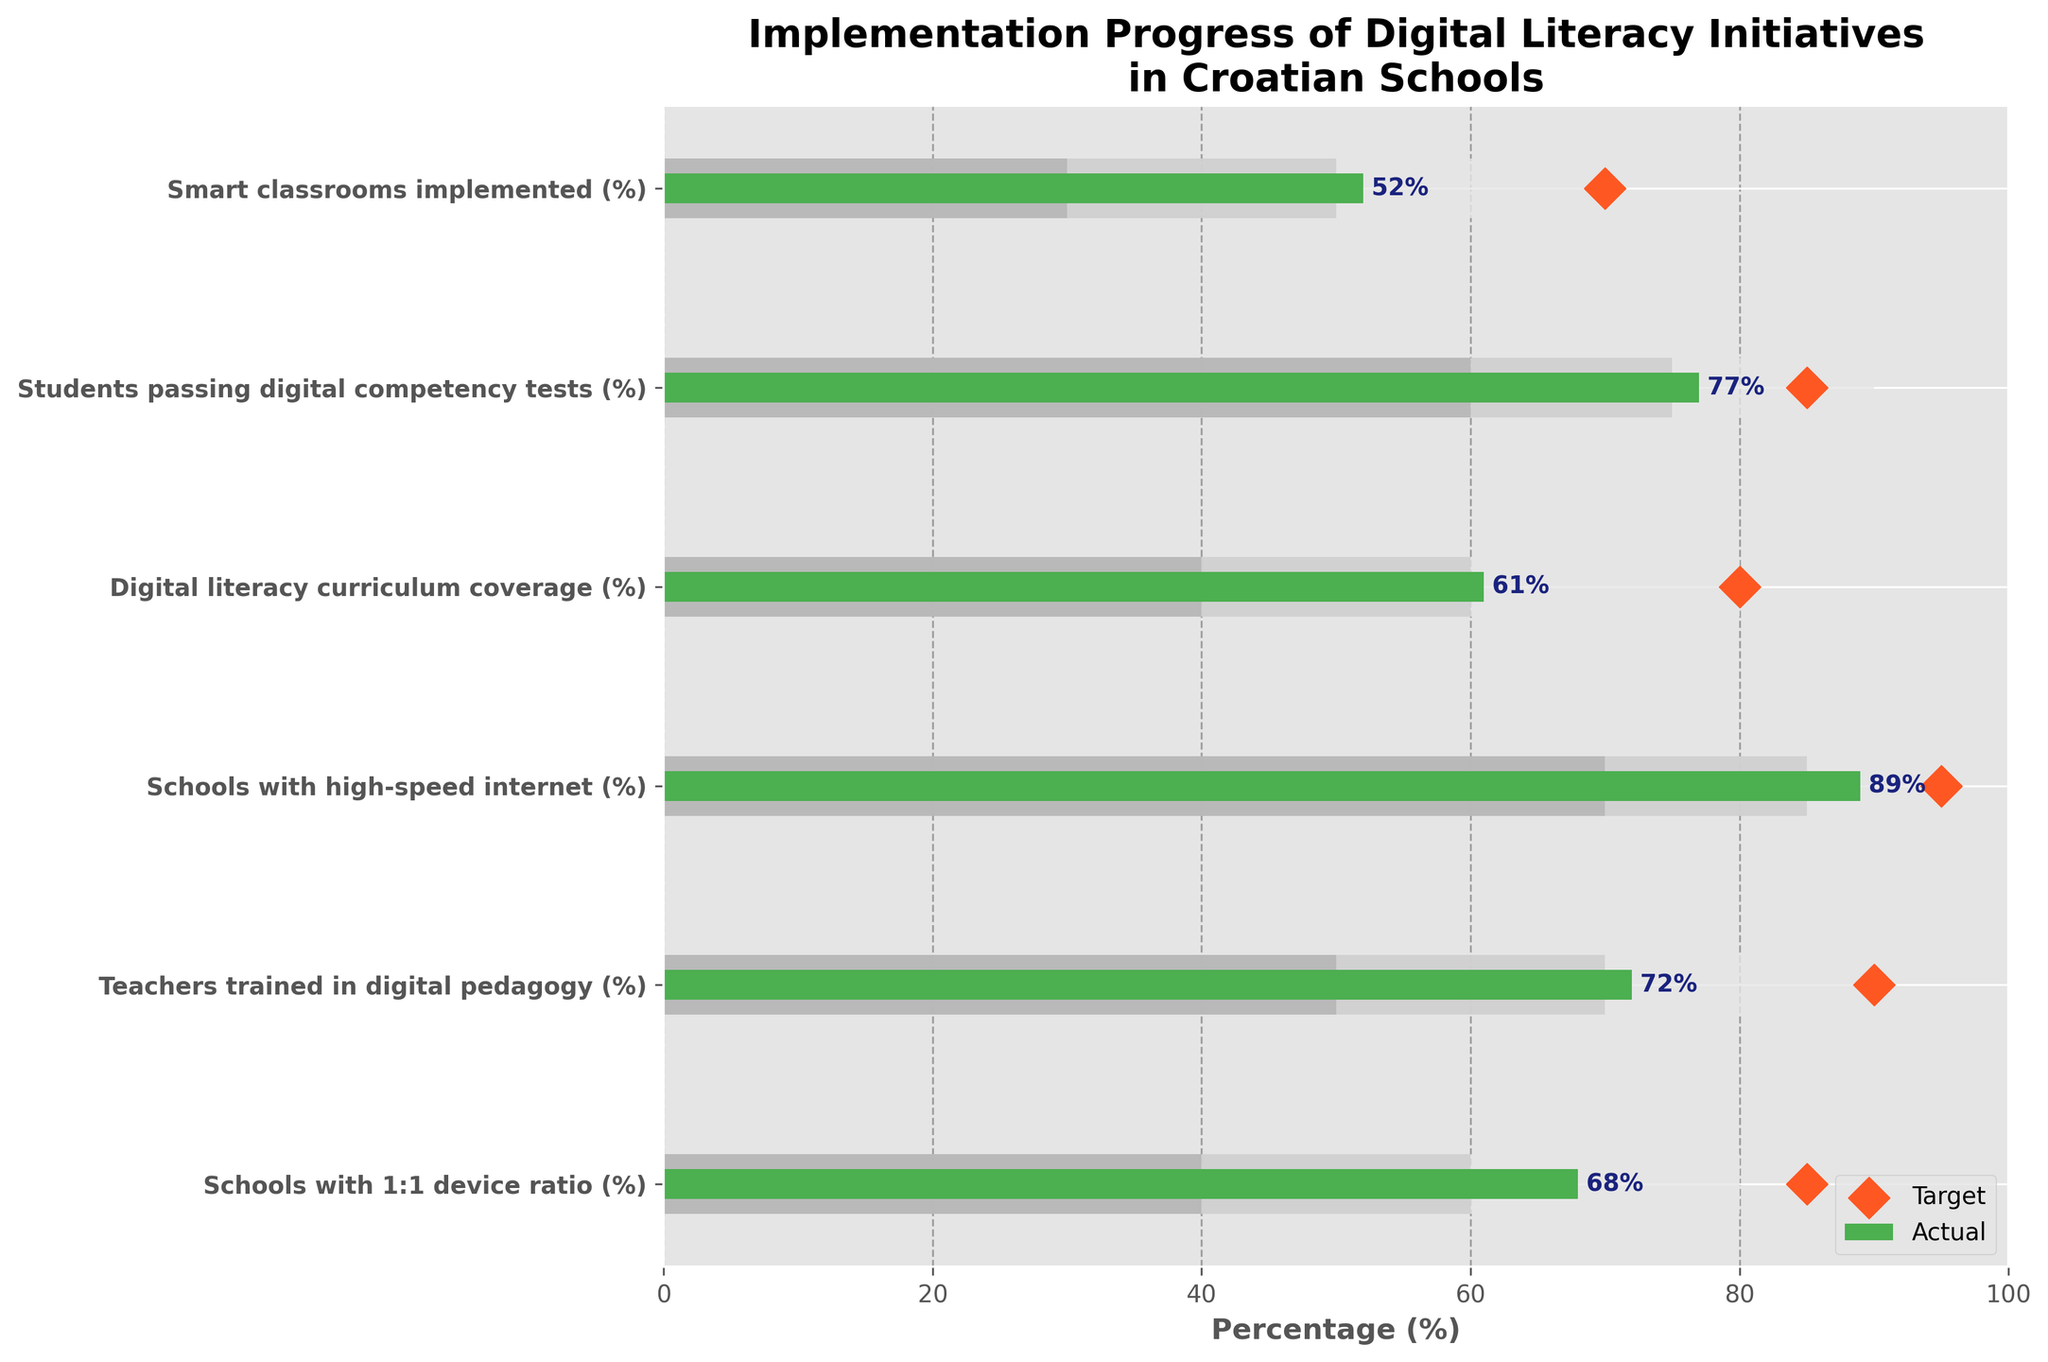What is the title of the figure? The title is usually found at the top of the figure. In this case, the title reads "Implementation Progress of Digital Literacy Initiatives in Croatian Schools."
Answer: Implementation Progress of Digital Literacy Initiatives in Croatian Schools How many categories are compared in the figure? The number of categories can be counted from the y-axis labels. In this figure, there are six listed categories: "Schools with 1:1 device ratio (%)," "Teachers trained in digital pedagogy (%)," "Schools with high-speed internet (%)," "Digital literacy curriculum coverage (%)," "Students passing digital competency tests (%)," and "Smart classrooms implemented (%)."
Answer: Six Which category has the highest actual value? By examining the actual values (green bars) on the horizontal axis, the category "Schools with high-speed internet (%)" has the highest actual value at 89%.
Answer: Schools with high-speed internet (%) Which category is farthest from reaching its target? To determine this, calculate the difference between the target and actual values for each category. The category "Teachers trained in digital pedagogy (%)” has a target of 90% and an actual value of 72%, which is a difference of 18%.
Answer: Teachers trained in digital pedagogy (%) How many categories exceed the 80% mark in their actual value? By looking at the green bars, only two categories exceed 80% in their actual value: "Schools with high-speed internet (%)" at 89% and "Students passing digital competency tests (%)" at 77% (which rounds to 80% if considered roughly).
Answer: Two What is the range for "Smart classrooms implemented (%)"? To find this, inspect the range bars for "Smart classrooms implemented (%)," which span from 0% to 30% (light gray), 30% to 50% (medium gray), and 50% to 70% (dark gray). Therefore, the complete range is from 0% to 70%.
Answer: 0% to 70% Compare “Digital literacy curriculum coverage (%)” and “Schools with 1:1 device ratio (%)” regarding their progress towards their targets. For "Digital literacy curriculum coverage (%)", the actual value is 61% and the target is 80%, so the gap is 19%. For "Schools with 1:1 device ratio (%)", the actual value is 68% and the target is 85%, creating a gap of 17%. Thus, "Digital literacy curriculum coverage (%)" is slightly further from its target.
Answer: Digital literacy curriculum coverage (%) is further from its target Which category has an actual value closest to its target? By subtracting the actual values from the target values for each category, we find that "Schools with high-speed internet (%)" (Actual: 89%, Target: 95%) has the smallest gap of 6%.
Answer: Schools with high-speed internet (%) Explain the significance of the differently shaded regions in the figure. In a Bullet Chart, shaded regions often represent qualitative performance ranges. Here, the various shades (from light gray to dark gray) indicate performance bands, such as 0-40% (light gray) for "unsatisfactory", 40-60% (medium gray) for "needs improvement", and 60-80% (dark gray) for "satisfactory". The actual values are compared against these performance bands to assess progress.
Answer: Performance bands from unsatisfactory to satisfactory Why are the targets marked with diamond shapes? Diamond shapes are used to clearly denote the target values on Bullet Charts. This makes it easy to visually distinguish where the goal is set relative to the actual performance values represented by the bar.
Answer: To clearly denote the target values 